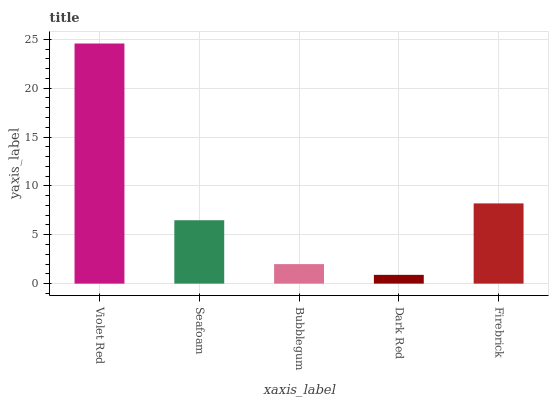Is Dark Red the minimum?
Answer yes or no. Yes. Is Violet Red the maximum?
Answer yes or no. Yes. Is Seafoam the minimum?
Answer yes or no. No. Is Seafoam the maximum?
Answer yes or no. No. Is Violet Red greater than Seafoam?
Answer yes or no. Yes. Is Seafoam less than Violet Red?
Answer yes or no. Yes. Is Seafoam greater than Violet Red?
Answer yes or no. No. Is Violet Red less than Seafoam?
Answer yes or no. No. Is Seafoam the high median?
Answer yes or no. Yes. Is Seafoam the low median?
Answer yes or no. Yes. Is Bubblegum the high median?
Answer yes or no. No. Is Bubblegum the low median?
Answer yes or no. No. 